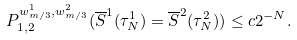Convert formula to latex. <formula><loc_0><loc_0><loc_500><loc_500>P ^ { w ^ { 1 } _ { m / 3 } , w ^ { 2 } _ { m / 3 } } _ { 1 , 2 } ( \overline { S } ^ { 1 } ( \tau ^ { 1 } _ { N } ) = \overline { S } ^ { 2 } ( \tau ^ { 2 } _ { N } ) ) \leq c 2 ^ { - N } .</formula> 